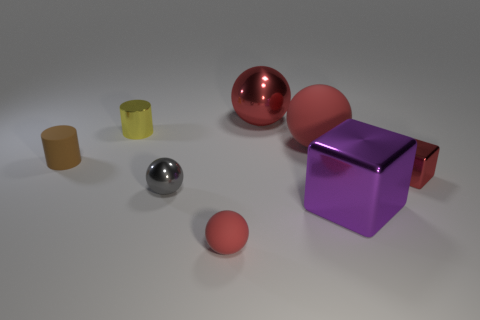What shape is the small red object that is made of the same material as the large purple cube?
Offer a terse response. Cube. There is a tiny brown matte thing; are there any tiny yellow metallic cylinders in front of it?
Keep it short and to the point. No. Are there fewer big red matte things that are on the right side of the tiny red metallic cube than purple metallic cubes?
Ensure brevity in your answer.  Yes. What material is the purple object?
Keep it short and to the point. Metal. What is the color of the big metallic cube?
Your response must be concise. Purple. What color is the object that is behind the rubber cylinder and to the left of the tiny red matte object?
Keep it short and to the point. Yellow. Are the purple cube and the thing that is in front of the purple metal thing made of the same material?
Provide a succinct answer. No. There is a red metal thing behind the cylinder in front of the yellow cylinder; what size is it?
Your answer should be compact. Large. Is there any other thing of the same color as the small metallic cylinder?
Your response must be concise. No. Is the brown cylinder on the left side of the large red matte object made of the same material as the large thing that is in front of the gray object?
Offer a very short reply. No. 